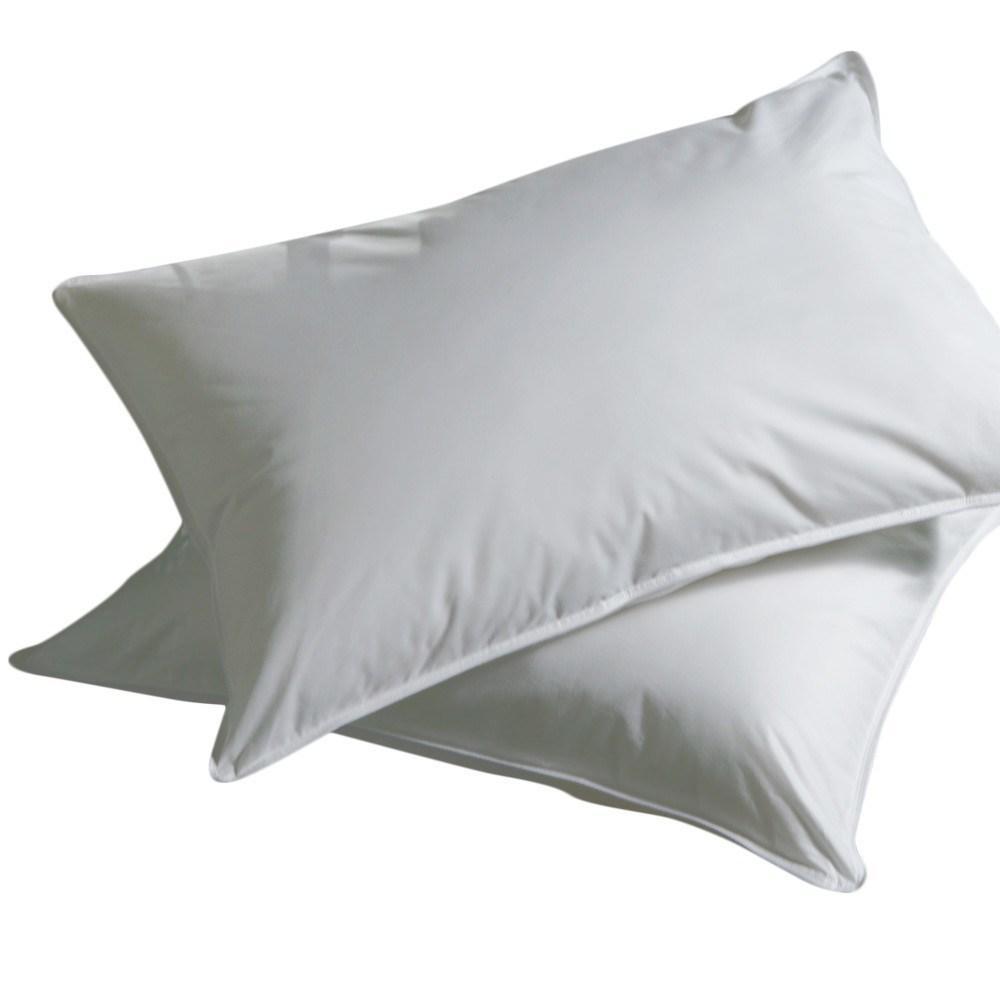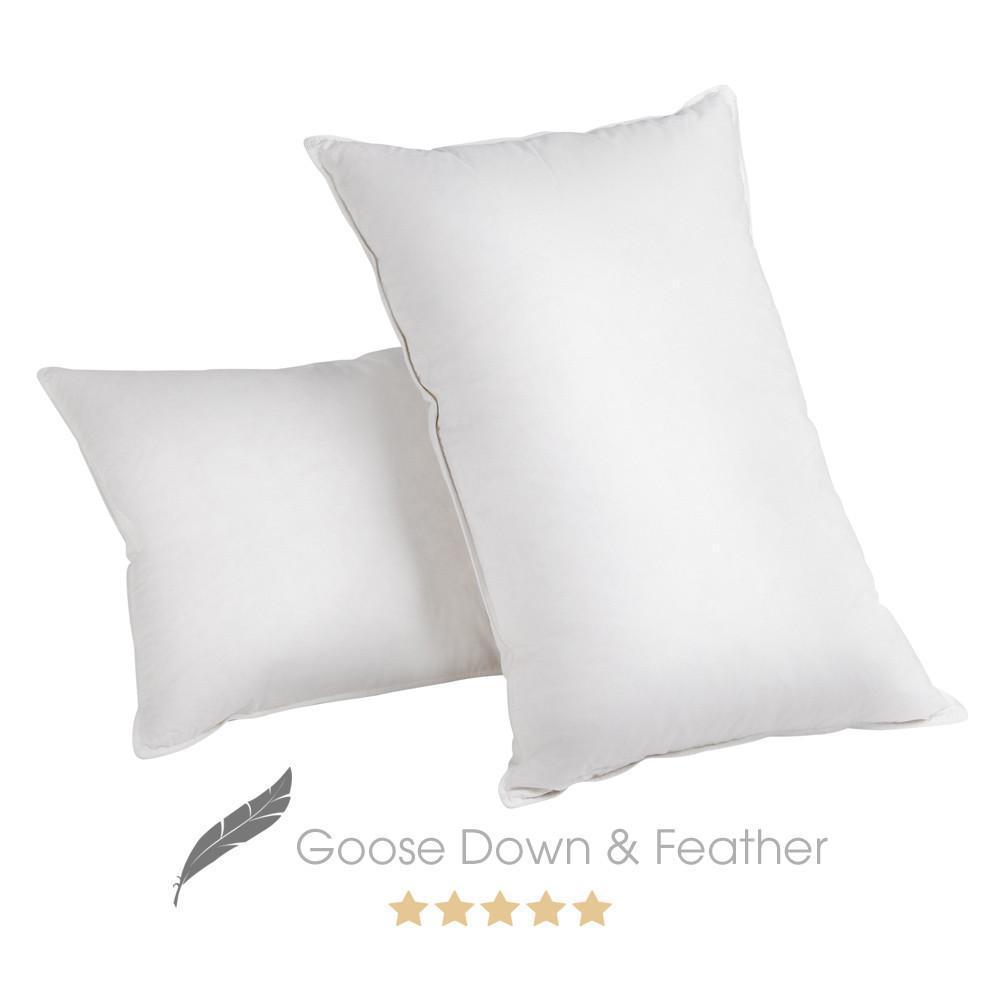The first image is the image on the left, the second image is the image on the right. For the images displayed, is the sentence "There are three or fewer pillows." factually correct? Answer yes or no. No. The first image is the image on the left, the second image is the image on the right. Examine the images to the left and right. Is the description "There are three or more white pillows that are resting on white mattresses." accurate? Answer yes or no. No. 